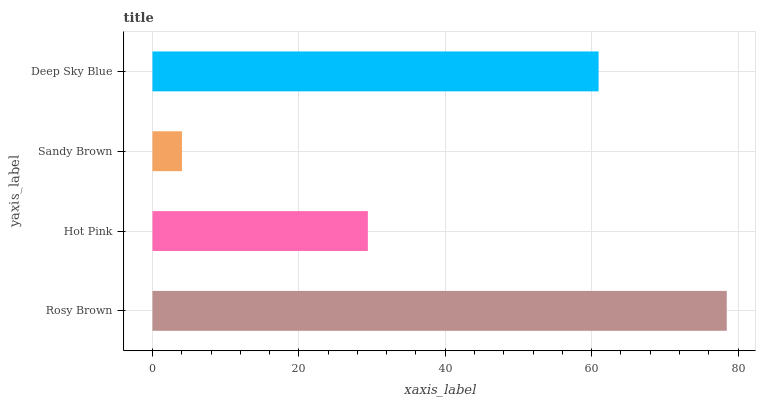Is Sandy Brown the minimum?
Answer yes or no. Yes. Is Rosy Brown the maximum?
Answer yes or no. Yes. Is Hot Pink the minimum?
Answer yes or no. No. Is Hot Pink the maximum?
Answer yes or no. No. Is Rosy Brown greater than Hot Pink?
Answer yes or no. Yes. Is Hot Pink less than Rosy Brown?
Answer yes or no. Yes. Is Hot Pink greater than Rosy Brown?
Answer yes or no. No. Is Rosy Brown less than Hot Pink?
Answer yes or no. No. Is Deep Sky Blue the high median?
Answer yes or no. Yes. Is Hot Pink the low median?
Answer yes or no. Yes. Is Sandy Brown the high median?
Answer yes or no. No. Is Rosy Brown the low median?
Answer yes or no. No. 